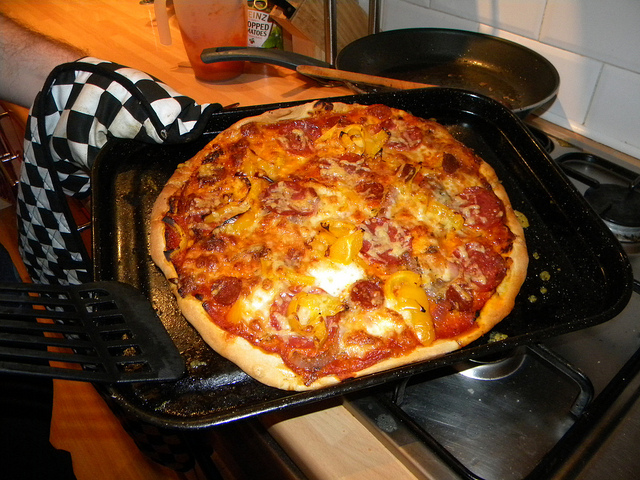Identify the text displayed in this image. MATOES OPPED INZ 